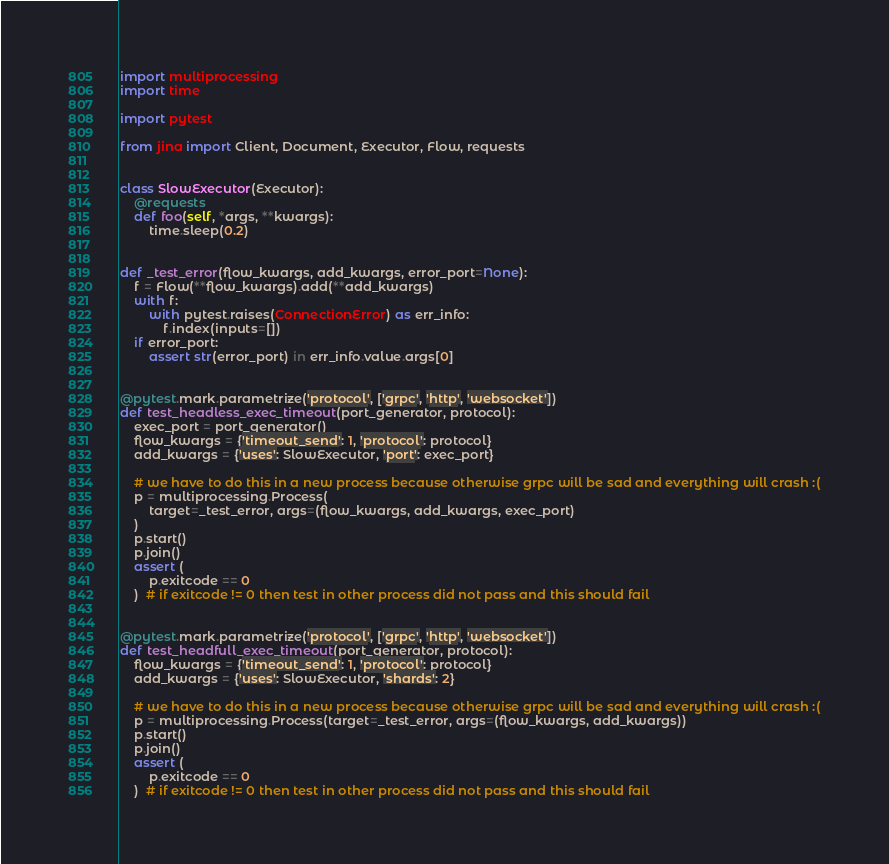<code> <loc_0><loc_0><loc_500><loc_500><_Python_>import multiprocessing
import time

import pytest

from jina import Client, Document, Executor, Flow, requests


class SlowExecutor(Executor):
    @requests
    def foo(self, *args, **kwargs):
        time.sleep(0.2)


def _test_error(flow_kwargs, add_kwargs, error_port=None):
    f = Flow(**flow_kwargs).add(**add_kwargs)
    with f:
        with pytest.raises(ConnectionError) as err_info:
            f.index(inputs=[])
    if error_port:
        assert str(error_port) in err_info.value.args[0]


@pytest.mark.parametrize('protocol', ['grpc', 'http', 'websocket'])
def test_headless_exec_timeout(port_generator, protocol):
    exec_port = port_generator()
    flow_kwargs = {'timeout_send': 1, 'protocol': protocol}
    add_kwargs = {'uses': SlowExecutor, 'port': exec_port}

    # we have to do this in a new process because otherwise grpc will be sad and everything will crash :(
    p = multiprocessing.Process(
        target=_test_error, args=(flow_kwargs, add_kwargs, exec_port)
    )
    p.start()
    p.join()
    assert (
        p.exitcode == 0
    )  # if exitcode != 0 then test in other process did not pass and this should fail


@pytest.mark.parametrize('protocol', ['grpc', 'http', 'websocket'])
def test_headfull_exec_timeout(port_generator, protocol):
    flow_kwargs = {'timeout_send': 1, 'protocol': protocol}
    add_kwargs = {'uses': SlowExecutor, 'shards': 2}

    # we have to do this in a new process because otherwise grpc will be sad and everything will crash :(
    p = multiprocessing.Process(target=_test_error, args=(flow_kwargs, add_kwargs))
    p.start()
    p.join()
    assert (
        p.exitcode == 0
    )  # if exitcode != 0 then test in other process did not pass and this should fail
</code> 